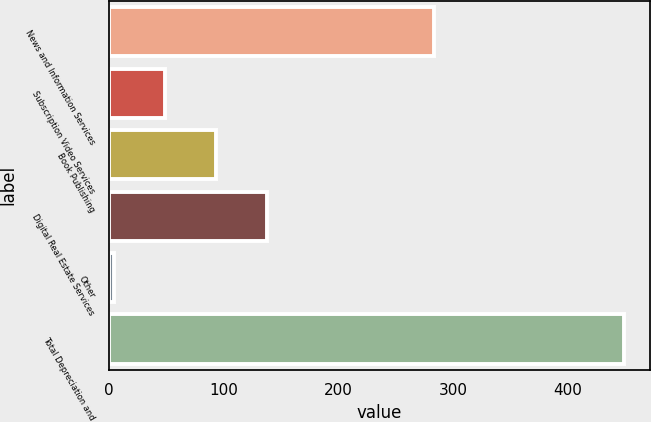Convert chart to OTSL. <chart><loc_0><loc_0><loc_500><loc_500><bar_chart><fcel>News and Information Services<fcel>Subscription Video Services<fcel>Book Publishing<fcel>Digital Real Estate Services<fcel>Other<fcel>Total Depreciation and<nl><fcel>283<fcel>48.5<fcel>93<fcel>137.5<fcel>4<fcel>449<nl></chart> 